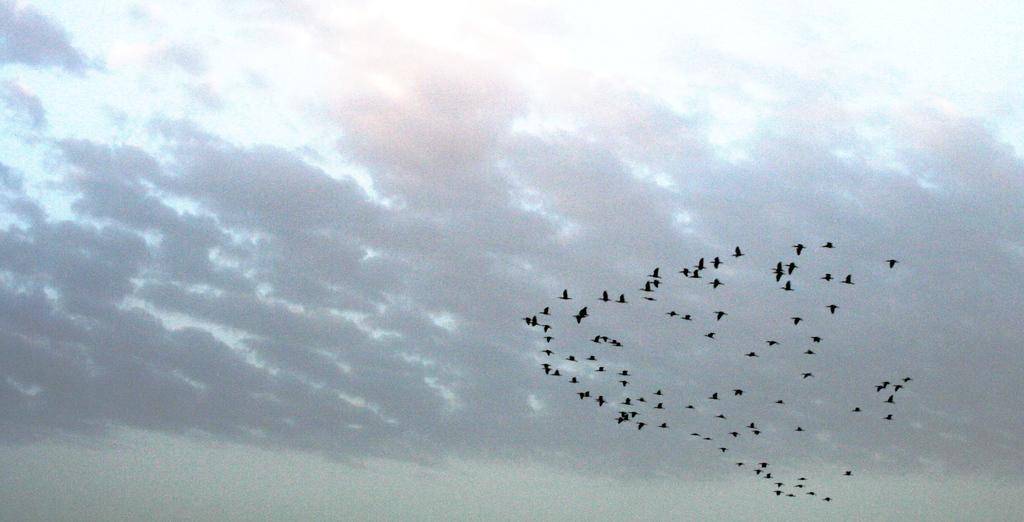What is the main focus of the image? The center of the image contains the sky. What can be seen in the sky? Clouds are visible in the sky. Are there any animals present in the image? Yes, there are birds flying in the sky. What is the color of the birds? The birds are in black color. What type of hat can be seen on the edge of the image? There is no hat present on the edge of the image. 